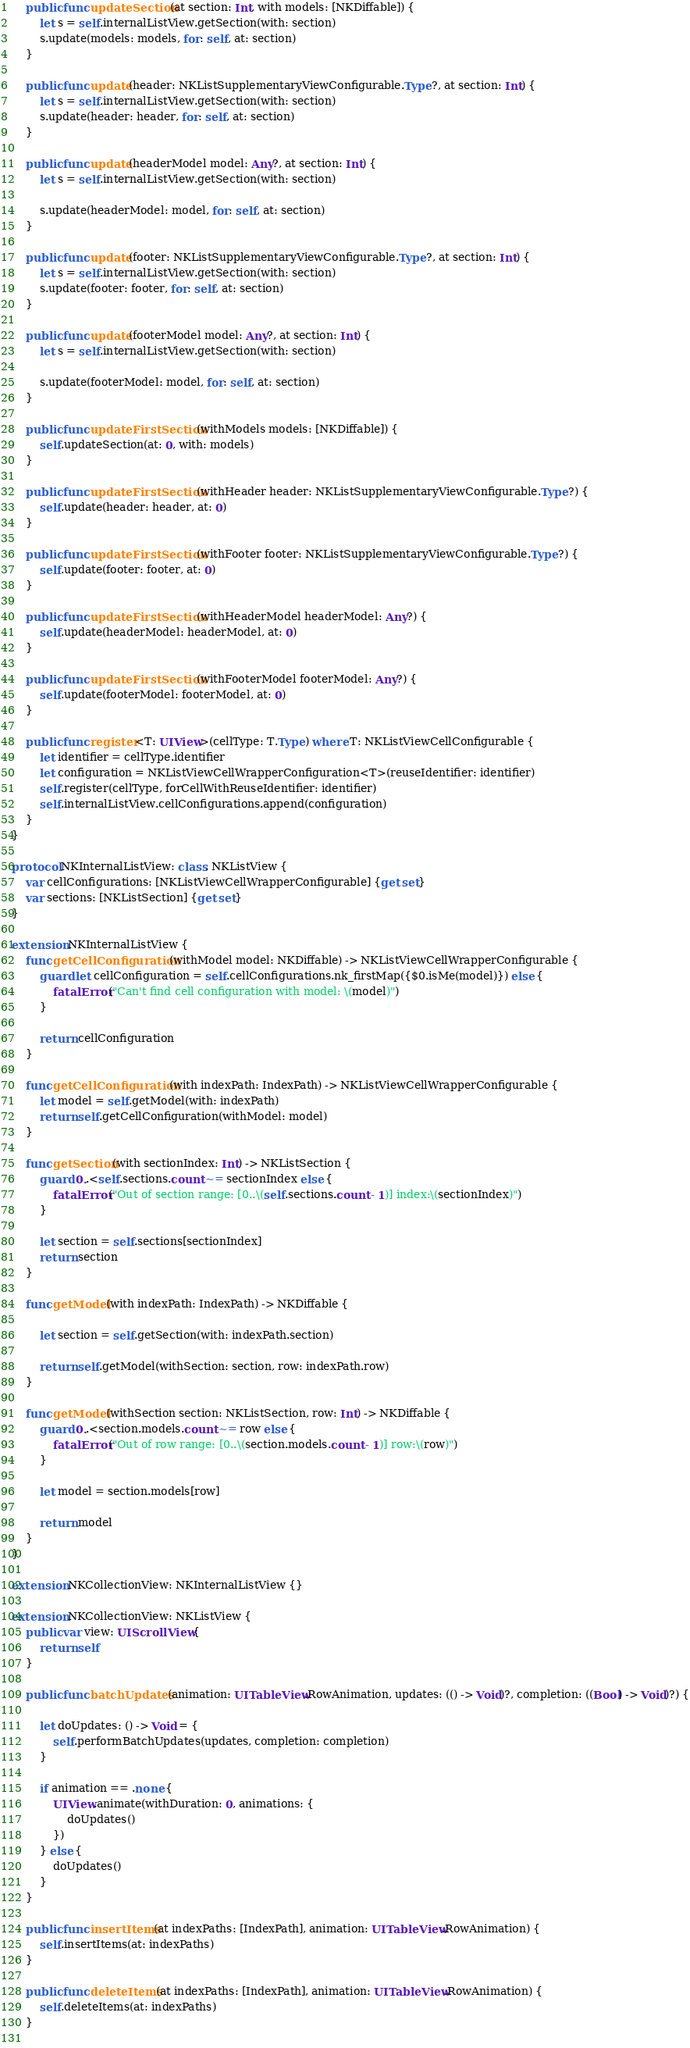Convert code to text. <code><loc_0><loc_0><loc_500><loc_500><_Swift_>    public func updateSection(at section: Int, with models: [NKDiffable]) {
        let s = self.internalListView.getSection(with: section)
        s.update(models: models, for: self, at: section)
    }
    
    public func update(header: NKListSupplementaryViewConfigurable.Type?, at section: Int) {
        let s = self.internalListView.getSection(with: section)
        s.update(header: header, for: self, at: section)
    }
    
    public func update(headerModel model: Any?, at section: Int) {
        let s = self.internalListView.getSection(with: section)
        
        s.update(headerModel: model, for: self, at: section)
    }
    
    public func update(footer: NKListSupplementaryViewConfigurable.Type?, at section: Int) {
        let s = self.internalListView.getSection(with: section)
        s.update(footer: footer, for: self, at: section)
    }
    
    public func update(footerModel model: Any?, at section: Int) {
        let s = self.internalListView.getSection(with: section)
        
        s.update(footerModel: model, for: self, at: section)
    }
    
    public func updateFirstSection(withModels models: [NKDiffable]) {
        self.updateSection(at: 0, with: models)
    }
    
    public func updateFirstSection(withHeader header: NKListSupplementaryViewConfigurable.Type?) {
        self.update(header: header, at: 0)
    }
    
    public func updateFirstSection(withFooter footer: NKListSupplementaryViewConfigurable.Type?) {
        self.update(footer: footer, at: 0)
    }
    
    public func updateFirstSection(withHeaderModel headerModel: Any?) {
        self.update(headerModel: headerModel, at: 0)
    }
    
    public func updateFirstSection(withFooterModel footerModel: Any?) {
        self.update(footerModel: footerModel, at: 0)
    }
    
    public func register<T: UIView>(cellType: T.Type) where T: NKListViewCellConfigurable {
        let identifier = cellType.identifier
        let configuration = NKListViewCellWrapperConfiguration<T>(reuseIdentifier: identifier)
        self.register(cellType, forCellWithReuseIdentifier: identifier)
        self.internalListView.cellConfigurations.append(configuration)
    }
}

protocol NKInternalListView: class, NKListView {
    var cellConfigurations: [NKListViewCellWrapperConfigurable] {get set}
    var sections: [NKListSection] {get set}
}

extension NKInternalListView {
    func getCellConfiguration(withModel model: NKDiffable) -> NKListViewCellWrapperConfigurable {
        guard let cellConfiguration = self.cellConfigurations.nk_firstMap({$0.isMe(model)}) else {
            fatalError("Can't find cell configuration with model: \(model)")
        }
        
        return cellConfiguration
    }
    
    func getCellConfiguration(with indexPath: IndexPath) -> NKListViewCellWrapperConfigurable {
        let model = self.getModel(with: indexPath)
        return self.getCellConfiguration(withModel: model)
    }
    
    func getSection(with sectionIndex: Int) -> NKListSection {
        guard 0..<self.sections.count ~= sectionIndex else {
            fatalError("Out of section range: [0..\(self.sections.count - 1)] index:\(sectionIndex)")
        }
        
        let section = self.sections[sectionIndex]
        return section
    }
    
    func getModel(with indexPath: IndexPath) -> NKDiffable {
        
        let section = self.getSection(with: indexPath.section)
        
        return self.getModel(withSection: section, row: indexPath.row)
    }
    
    func getModel(withSection section: NKListSection, row: Int) -> NKDiffable {
        guard 0..<section.models.count ~= row else {
            fatalError("Out of row range: [0..\(section.models.count - 1)] row:\(row)")
        }
        
        let model = section.models[row]
        
        return model
    }
}

extension NKCollectionView: NKInternalListView {}

extension NKCollectionView: NKListView {
    public var view: UIScrollView {
        return self
    }
    
    public func batchUpdates(animation: UITableView.RowAnimation, updates: (() -> Void)?, completion: ((Bool) -> Void)?) {
        
        let doUpdates: () -> Void = {
            self.performBatchUpdates(updates, completion: completion)
        }
        
        if animation == .none {
            UIView.animate(withDuration: 0, animations: {
                doUpdates()
            })
        } else {
            doUpdates()
        }
    }
    
    public func insertItems(at indexPaths: [IndexPath], animation: UITableView.RowAnimation) {
        self.insertItems(at: indexPaths)
    }
    
    public func deleteItems(at indexPaths: [IndexPath], animation: UITableView.RowAnimation) {
        self.deleteItems(at: indexPaths)
    }
    </code> 